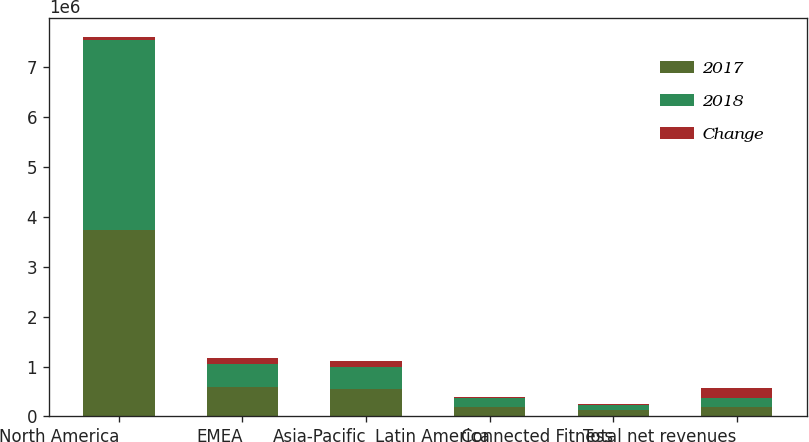Convert chart to OTSL. <chart><loc_0><loc_0><loc_500><loc_500><stacked_bar_chart><ecel><fcel>North America<fcel>EMEA<fcel>Asia-Pacific<fcel>Latin America<fcel>Connected Fitness<fcel>Total net revenues<nl><fcel>2017<fcel>3.73529e+06<fcel>588580<fcel>558160<fcel>190795<fcel>120357<fcel>186060<nl><fcel>2018<fcel>3.80241e+06<fcel>469996<fcel>433648<fcel>181324<fcel>101870<fcel>186060<nl><fcel>Change<fcel>67113<fcel>118584<fcel>124512<fcel>9471<fcel>18487<fcel>203941<nl></chart> 